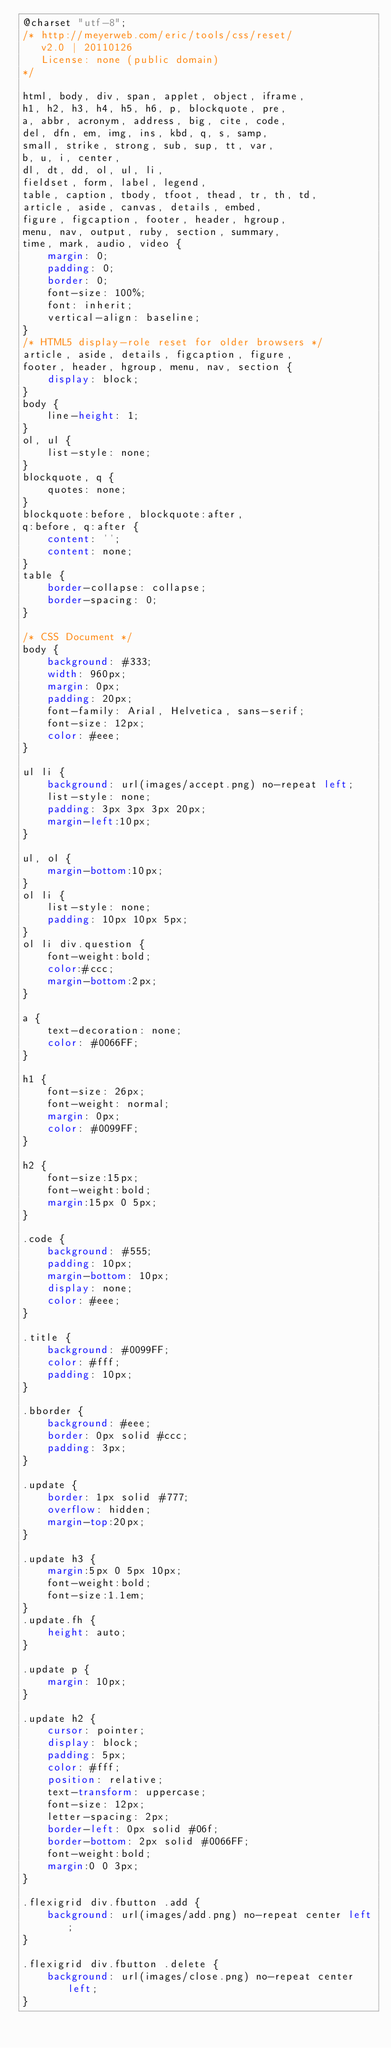<code> <loc_0><loc_0><loc_500><loc_500><_CSS_>@charset "utf-8";
/* http://meyerweb.com/eric/tools/css/reset/ 
   v2.0 | 20110126
   License: none (public domain)
*/

html, body, div, span, applet, object, iframe,
h1, h2, h3, h4, h5, h6, p, blockquote, pre,
a, abbr, acronym, address, big, cite, code,
del, dfn, em, img, ins, kbd, q, s, samp,
small, strike, strong, sub, sup, tt, var,
b, u, i, center,
dl, dt, dd, ol, ul, li,
fieldset, form, label, legend,
table, caption, tbody, tfoot, thead, tr, th, td,
article, aside, canvas, details, embed, 
figure, figcaption, footer, header, hgroup, 
menu, nav, output, ruby, section, summary,
time, mark, audio, video {
	margin: 0;
	padding: 0;
	border: 0;
	font-size: 100%;
	font: inherit;
	vertical-align: baseline;
}
/* HTML5 display-role reset for older browsers */
article, aside, details, figcaption, figure, 
footer, header, hgroup, menu, nav, section {
	display: block;
}
body {
	line-height: 1;
}
ol, ul {
	list-style: none;
}
blockquote, q {
	quotes: none;
}
blockquote:before, blockquote:after,
q:before, q:after {
	content: '';
	content: none;
}
table {
	border-collapse: collapse;
	border-spacing: 0;
}

/* CSS Document */
body {
	background: #333;
	width: 960px;
	margin: 0px;
	padding: 20px;
	font-family: Arial, Helvetica, sans-serif;
	font-size: 12px;
	color: #eee;
}

ul li {
	background: url(images/accept.png) no-repeat left;
	list-style: none;
	padding: 3px 3px 3px 20px;
	margin-left:10px;
}

ul, ol {
	margin-bottom:10px;
}
ol li {
	list-style: none;
	padding: 10px 10px 5px;
}
ol li div.question {
	font-weight:bold;
	color:#ccc;
	margin-bottom:2px;
}

a {
	text-decoration: none;
	color: #0066FF;
}

h1 {
	font-size: 26px;
	font-weight: normal;
	margin: 0px;
	color: #0099FF;
}

h2 {
	font-size:15px;
	font-weight:bold;
	margin:15px 0 5px;	
}

.code {
	background: #555;
	padding: 10px;
	margin-bottom: 10px;
	display: none;
	color: #eee;
}

.title {
	background: #0099FF;
	color: #fff;
	padding: 10px;
}

.bborder {
	background: #eee;
	border: 0px solid #ccc;
	padding: 3px;
}

.update {
	border: 1px solid #777;
	overflow: hidden;
	margin-top:20px;
}

.update h3 {
	margin:5px 0 5px 10px;
	font-weight:bold;
	font-size:1.1em;	
}
.update.fh {
	height: auto;
}

.update p {
	margin: 10px;
}

.update h2 {
	cursor: pointer;
	display: block;
	padding: 5px;
	color: #fff;
	position: relative;
	text-transform: uppercase;
	font-size: 12px;
	letter-spacing: 2px;
	border-left: 0px solid #06f;
	border-bottom: 2px solid #0066FF;
	font-weight:bold;
	margin:0 0 3px;
}

.flexigrid div.fbutton .add {
	background: url(images/add.png) no-repeat center left;
}

.flexigrid div.fbutton .delete {
	background: url(images/close.png) no-repeat center left;
}</code> 